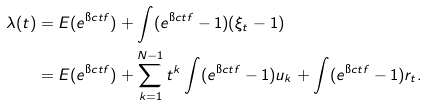Convert formula to latex. <formula><loc_0><loc_0><loc_500><loc_500>\lambda ( t ) & = E ( e ^ { \i c t f } ) + \int ( e ^ { \i c t f } - 1 ) ( \xi _ { t } - 1 ) \\ & = E ( e ^ { \i c t f } ) + \sum _ { k = 1 } ^ { N - 1 } t ^ { k } \int ( e ^ { \i c t f } - 1 ) u _ { k } + \int ( e ^ { \i c t f } - 1 ) r _ { t } .</formula> 